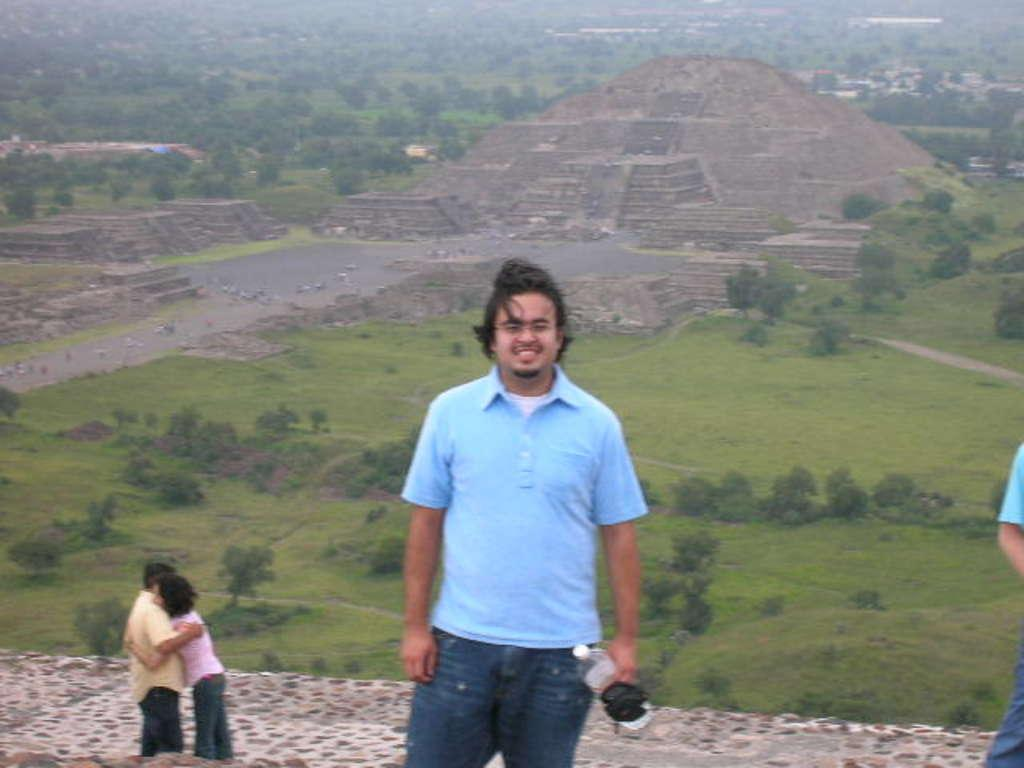What is the person in the image doing? The person in the image is standing and smiling. What is the person holding in the image? The person is holding a bottle. How many other people are in the image? There are three other persons in the image. What can be seen in the background of the image? There are trees and a pyramid-like structure in the background of the image. What is the person's opinion on debt in the image? There is no mention of debt in the image, so it is not possible to determine the person's opinion on the subject. 